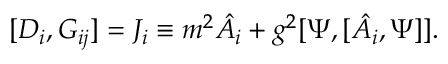<formula> <loc_0><loc_0><loc_500><loc_500>[ D _ { i } , G _ { i j } ] = J _ { i } \equiv m ^ { 2 } \hat { A } _ { i } + g ^ { 2 } [ \Psi , [ \hat { A } _ { i } , \Psi ] ] .</formula> 